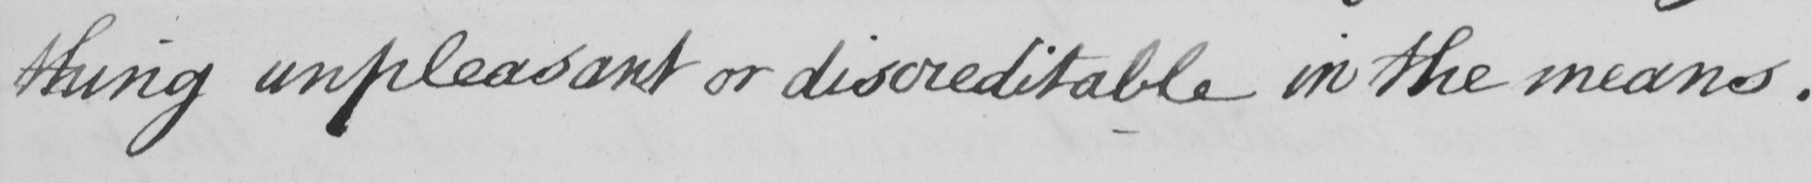Can you read and transcribe this handwriting? thing unpleasant or discreditable in the means . 